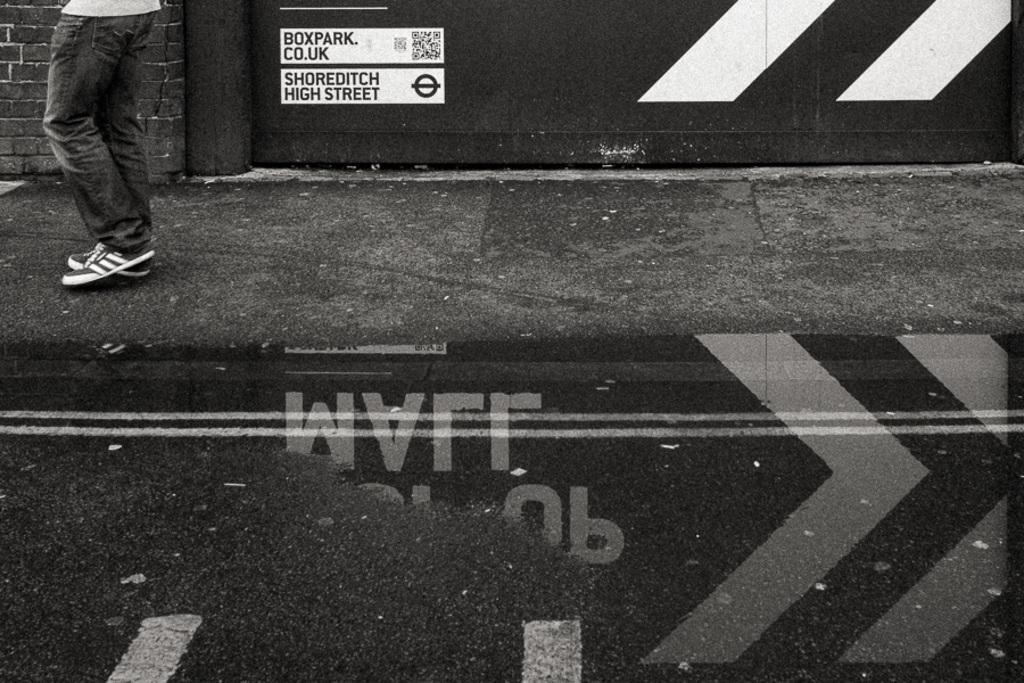Please provide a concise description of this image. In the foreground of this black and white image, at the bottom, there is a road and water. At the top left, there is a person and behind, there is a wall. 